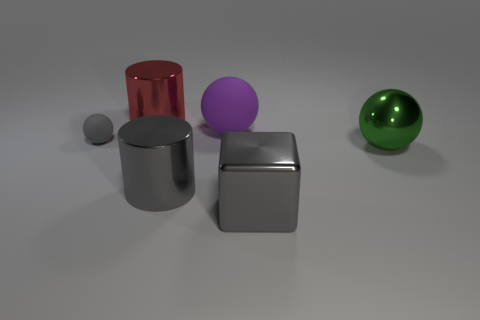There is a sphere that is the same color as the big metallic cube; what size is it?
Make the answer very short. Small. What number of other small gray matte objects are the same shape as the tiny gray rubber thing?
Give a very brief answer. 0. What is the shape of the green metallic thing that is the same size as the red shiny cylinder?
Ensure brevity in your answer.  Sphere. There is a gray metallic block; are there any large metal balls in front of it?
Offer a terse response. No. Is there a thing that is on the left side of the purple matte sphere behind the large gray cylinder?
Provide a short and direct response. Yes. Is the number of gray objects right of the big red metallic cylinder less than the number of gray metal cubes that are behind the large matte ball?
Keep it short and to the point. No. Are there any other things that are the same size as the gray rubber ball?
Ensure brevity in your answer.  No. What is the shape of the big green object?
Provide a succinct answer. Sphere. There is a small gray object that is in front of the big rubber thing; what is it made of?
Your answer should be very brief. Rubber. There is a cylinder in front of the big metallic object that is on the left side of the shiny cylinder that is in front of the small gray rubber object; what size is it?
Provide a succinct answer. Large. 